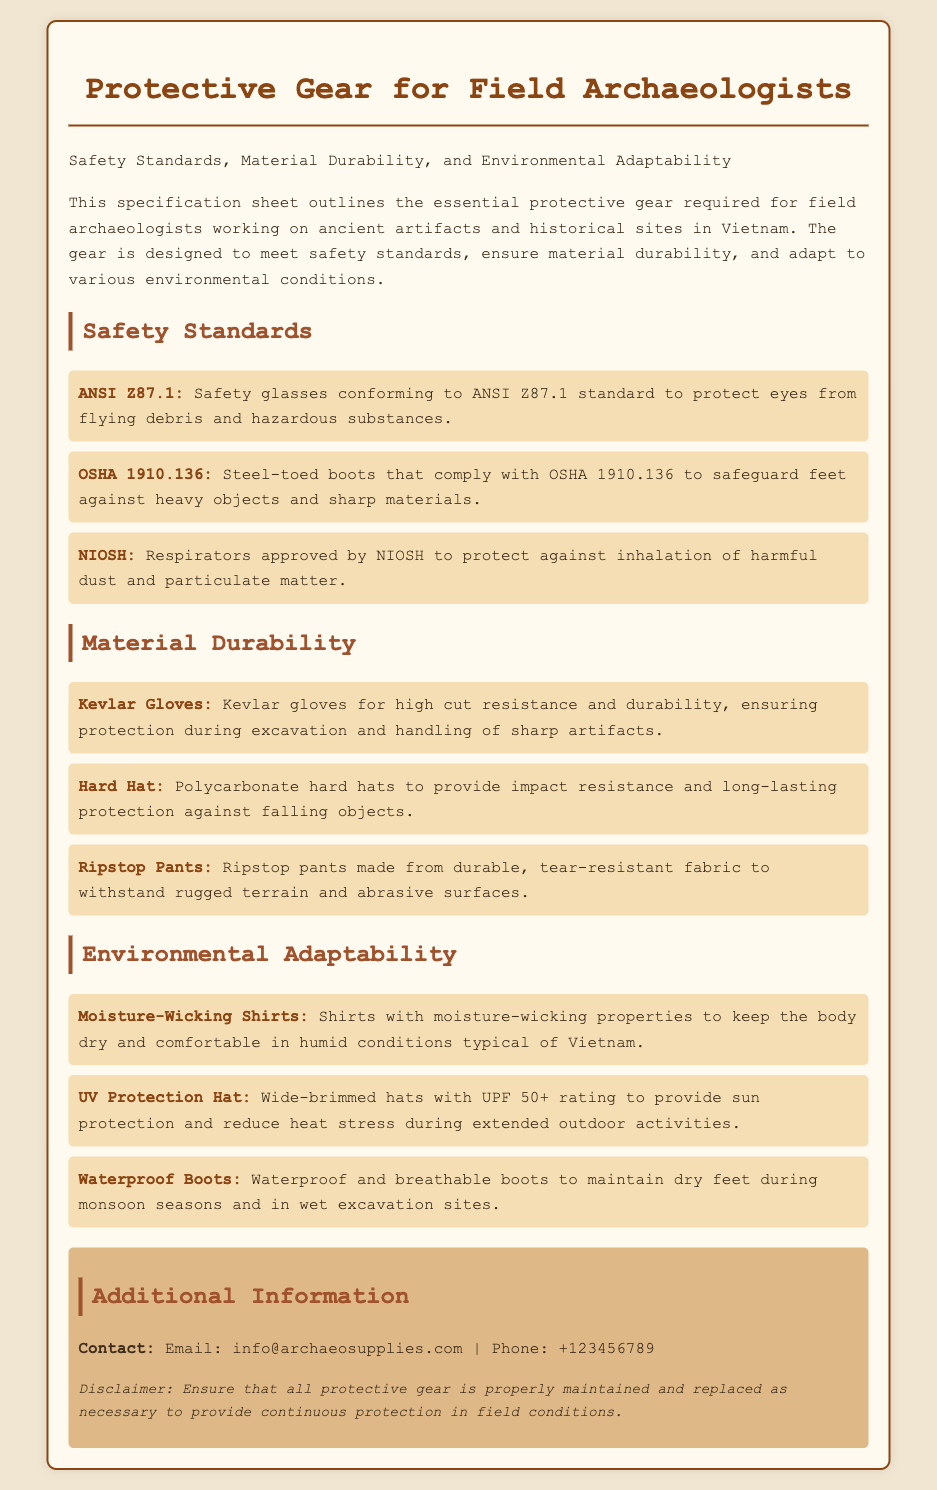What is the standard for safety glasses? The document specifies that safety glasses conform to the ANSI Z87.1 standard.
Answer: ANSI Z87.1 What type of gloves are recommended for high cut resistance? The specification sheet recommends Kevlar gloves for high cut resistance.
Answer: Kevlar Gloves What does UPF stand for in relation to the hats? UPF stands for Ultraviolet Protection Factor, indicating the level of sun protection the hats provide.
Answer: Ultraviolet Protection Factor How many safety standards are listed in the document? There are three safety standards mentioned for protective gear in the document.
Answer: Three What material is the hard hat made of? The hard hat is made of polycarbonate for impact resistance.
Answer: Polycarbonate Which garment helps keep the body dry in humid conditions? Moisture-wicking shirts are designed to keep the body dry in humid conditions.
Answer: Moisture-wicking Shirts What rating do the hats have for sun protection? The hats have a UPF 50+ rating for sun protection.
Answer: UPF 50+ What type of boots are recommended for wet excavation sites? The recommended boots for wet excavation sites are waterproof and breathable boots.
Answer: Waterproof Boots What is the contact email provided for further information? The contact email for further information is info@archaeosupplies.com.
Answer: info@archaeosupplies.com 